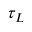<formula> <loc_0><loc_0><loc_500><loc_500>\tau _ { L }</formula> 